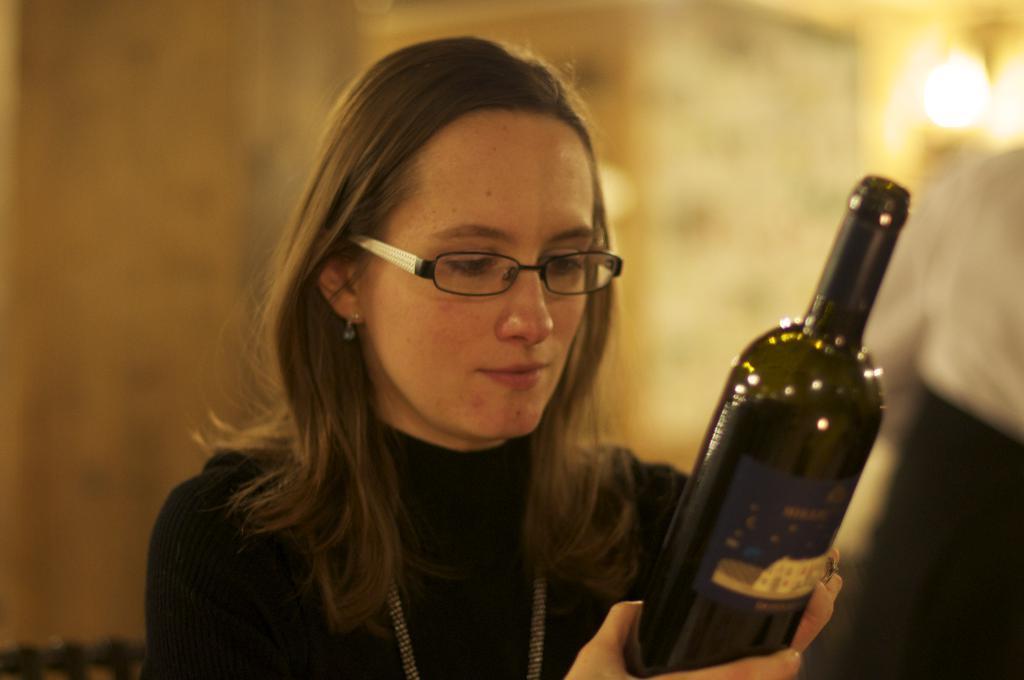How would you summarize this image in a sentence or two? In this image there is a woman smiling and holding a bottle in her hand, and at the back ground there is a wall and light. 